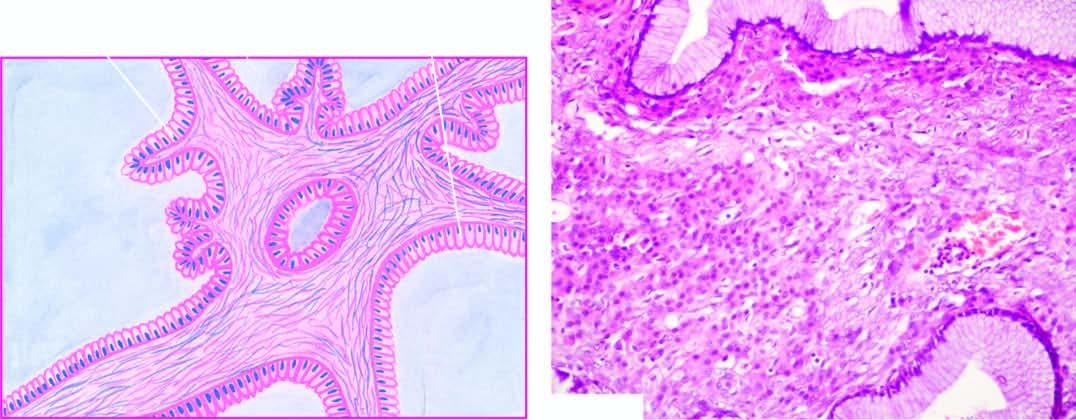what are lined by a single layer of tall columnar mucin-secreting epithelium with basally-placed nuclei and large apical mucinous vacuoles?
Answer the question using a single word or phrase. Cyst wall and the septa 